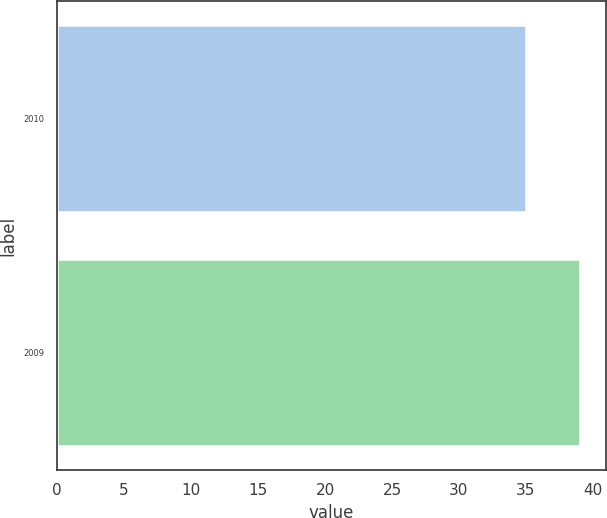Convert chart. <chart><loc_0><loc_0><loc_500><loc_500><bar_chart><fcel>2010<fcel>2009<nl><fcel>35<fcel>39<nl></chart> 